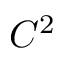Convert formula to latex. <formula><loc_0><loc_0><loc_500><loc_500>C ^ { 2 }</formula> 